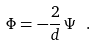Convert formula to latex. <formula><loc_0><loc_0><loc_500><loc_500>\Phi = - \frac { 2 } { d } \, \Psi \ .</formula> 